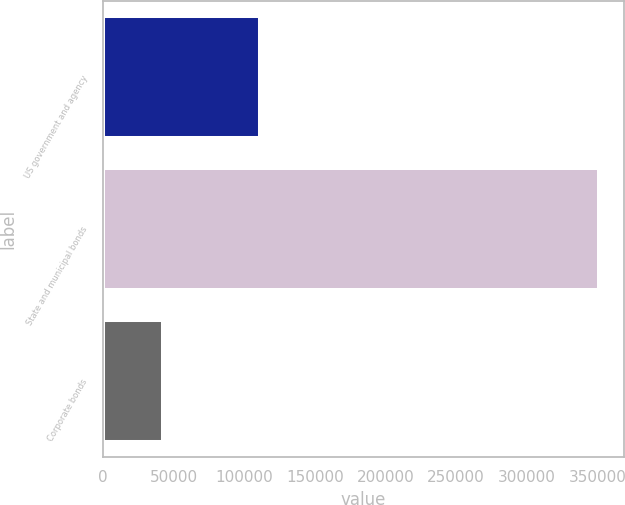<chart> <loc_0><loc_0><loc_500><loc_500><bar_chart><fcel>US government and agency<fcel>State and municipal bonds<fcel>Corporate bonds<nl><fcel>111492<fcel>351141<fcel>42757<nl></chart> 